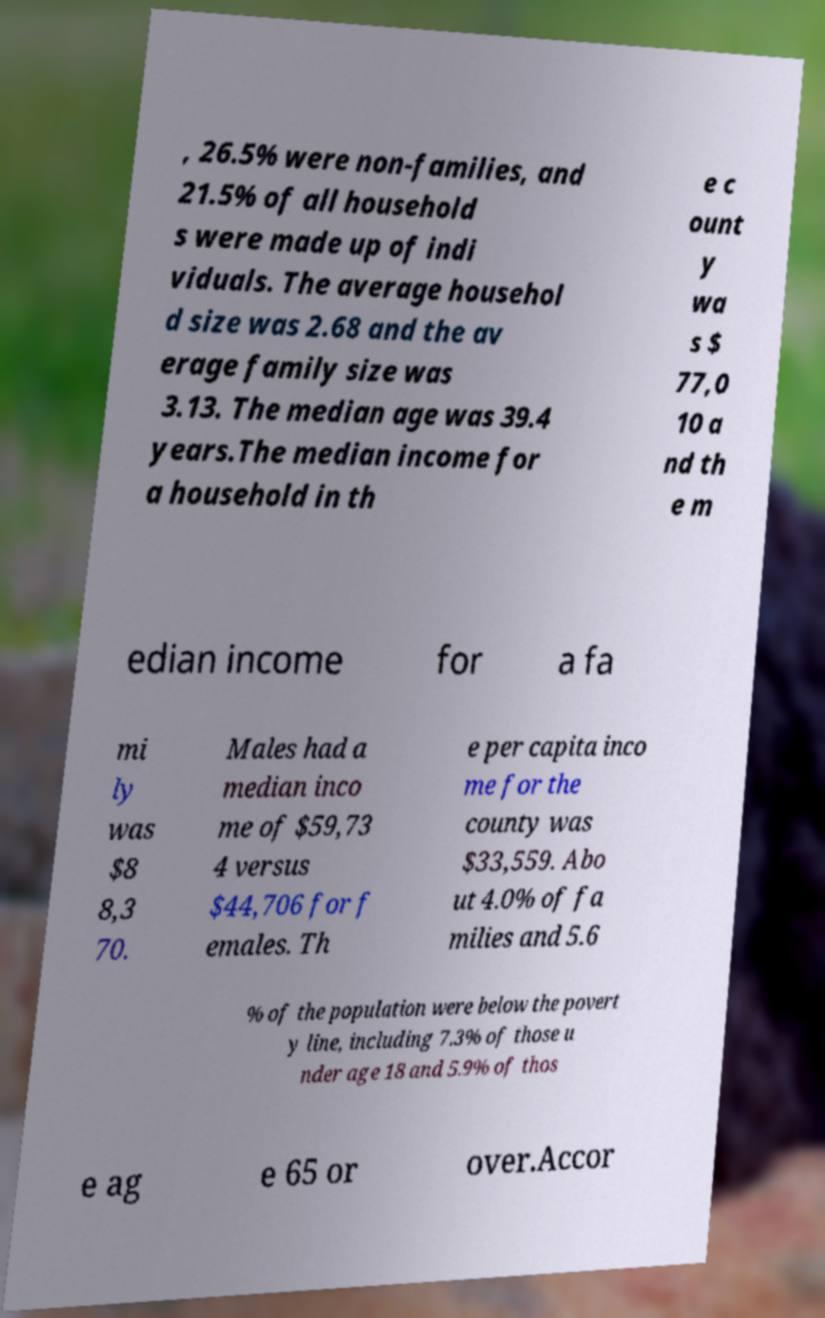There's text embedded in this image that I need extracted. Can you transcribe it verbatim? , 26.5% were non-families, and 21.5% of all household s were made up of indi viduals. The average househol d size was 2.68 and the av erage family size was 3.13. The median age was 39.4 years.The median income for a household in th e c ount y wa s $ 77,0 10 a nd th e m edian income for a fa mi ly was $8 8,3 70. Males had a median inco me of $59,73 4 versus $44,706 for f emales. Th e per capita inco me for the county was $33,559. Abo ut 4.0% of fa milies and 5.6 % of the population were below the povert y line, including 7.3% of those u nder age 18 and 5.9% of thos e ag e 65 or over.Accor 